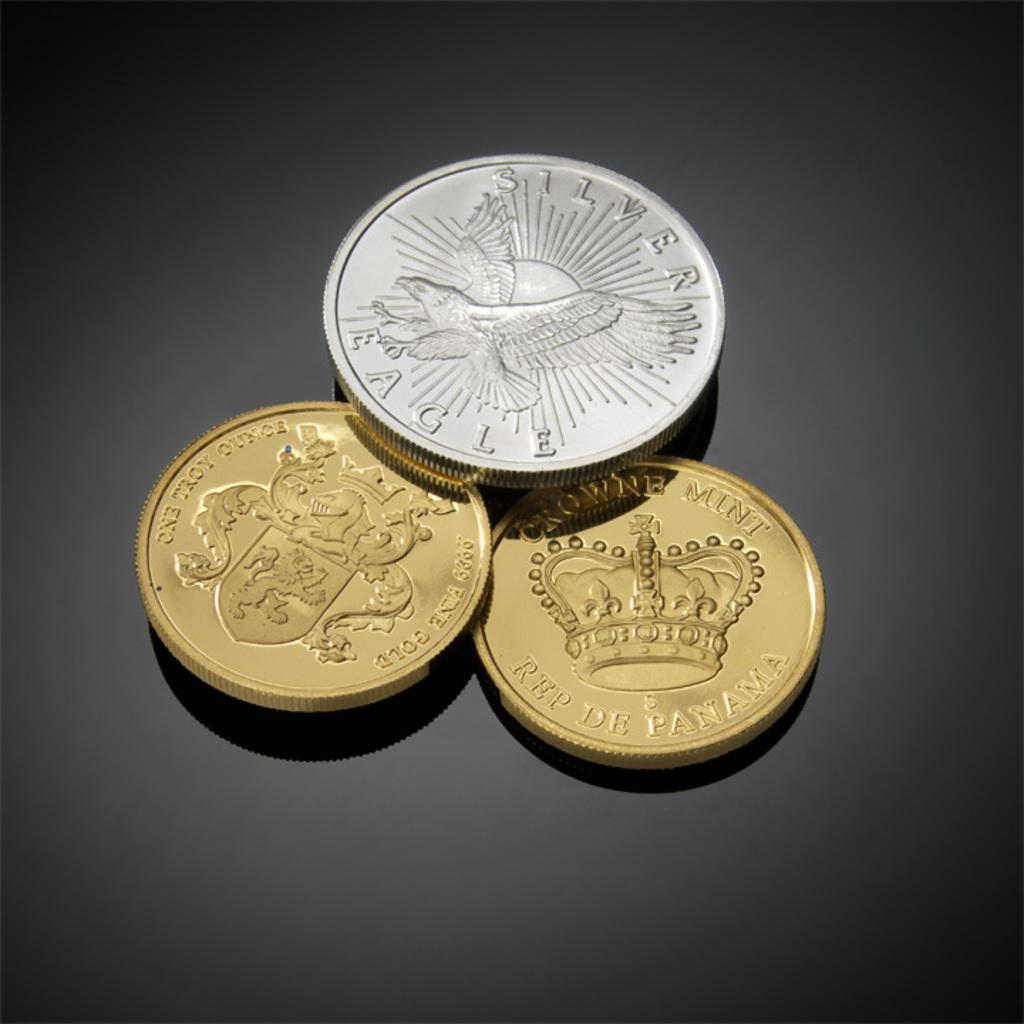<image>
Create a compact narrative representing the image presented. A silver eagle coin lies on top of two smaller bronze coins with a crown on them. 